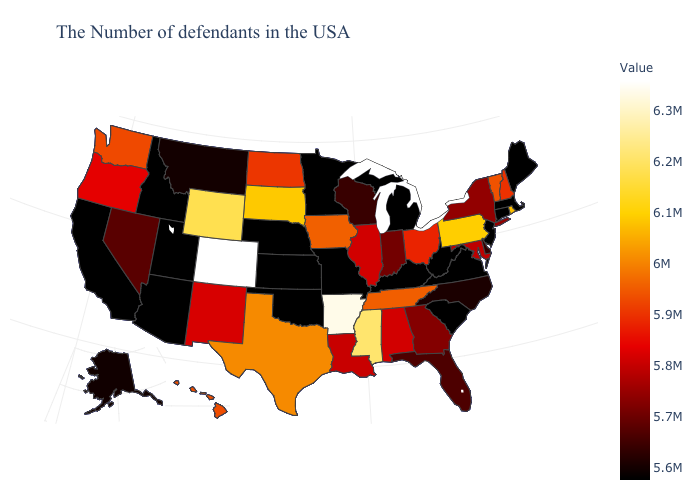Does West Virginia have the lowest value in the USA?
Short answer required. Yes. Among the states that border Pennsylvania , does New York have the lowest value?
Quick response, please. No. Does South Carolina have the lowest value in the USA?
Give a very brief answer. Yes. Is the legend a continuous bar?
Quick response, please. Yes. Which states have the lowest value in the South?
Write a very short answer. Virginia, South Carolina, West Virginia, Kentucky, Oklahoma. 